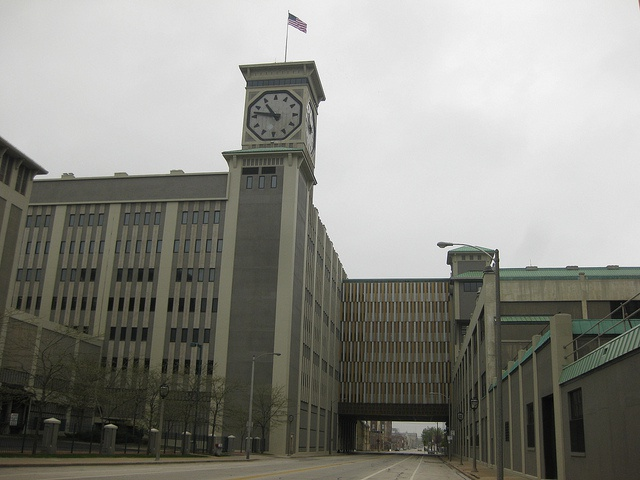Describe the objects in this image and their specific colors. I can see clock in lightgray, gray, and black tones and clock in lightgray, darkgray, gray, and black tones in this image. 